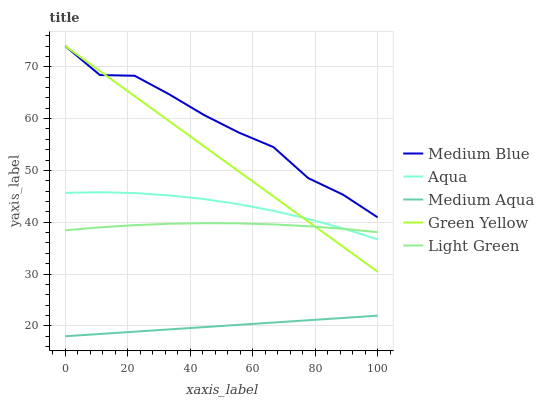Does Medium Aqua have the minimum area under the curve?
Answer yes or no. Yes. Does Medium Blue have the maximum area under the curve?
Answer yes or no. Yes. Does Aqua have the minimum area under the curve?
Answer yes or no. No. Does Aqua have the maximum area under the curve?
Answer yes or no. No. Is Medium Aqua the smoothest?
Answer yes or no. Yes. Is Medium Blue the roughest?
Answer yes or no. Yes. Is Aqua the smoothest?
Answer yes or no. No. Is Aqua the roughest?
Answer yes or no. No. Does Medium Aqua have the lowest value?
Answer yes or no. Yes. Does Aqua have the lowest value?
Answer yes or no. No. Does Medium Blue have the highest value?
Answer yes or no. Yes. Does Aqua have the highest value?
Answer yes or no. No. Is Medium Aqua less than Aqua?
Answer yes or no. Yes. Is Medium Blue greater than Medium Aqua?
Answer yes or no. Yes. Does Aqua intersect Green Yellow?
Answer yes or no. Yes. Is Aqua less than Green Yellow?
Answer yes or no. No. Is Aqua greater than Green Yellow?
Answer yes or no. No. Does Medium Aqua intersect Aqua?
Answer yes or no. No. 